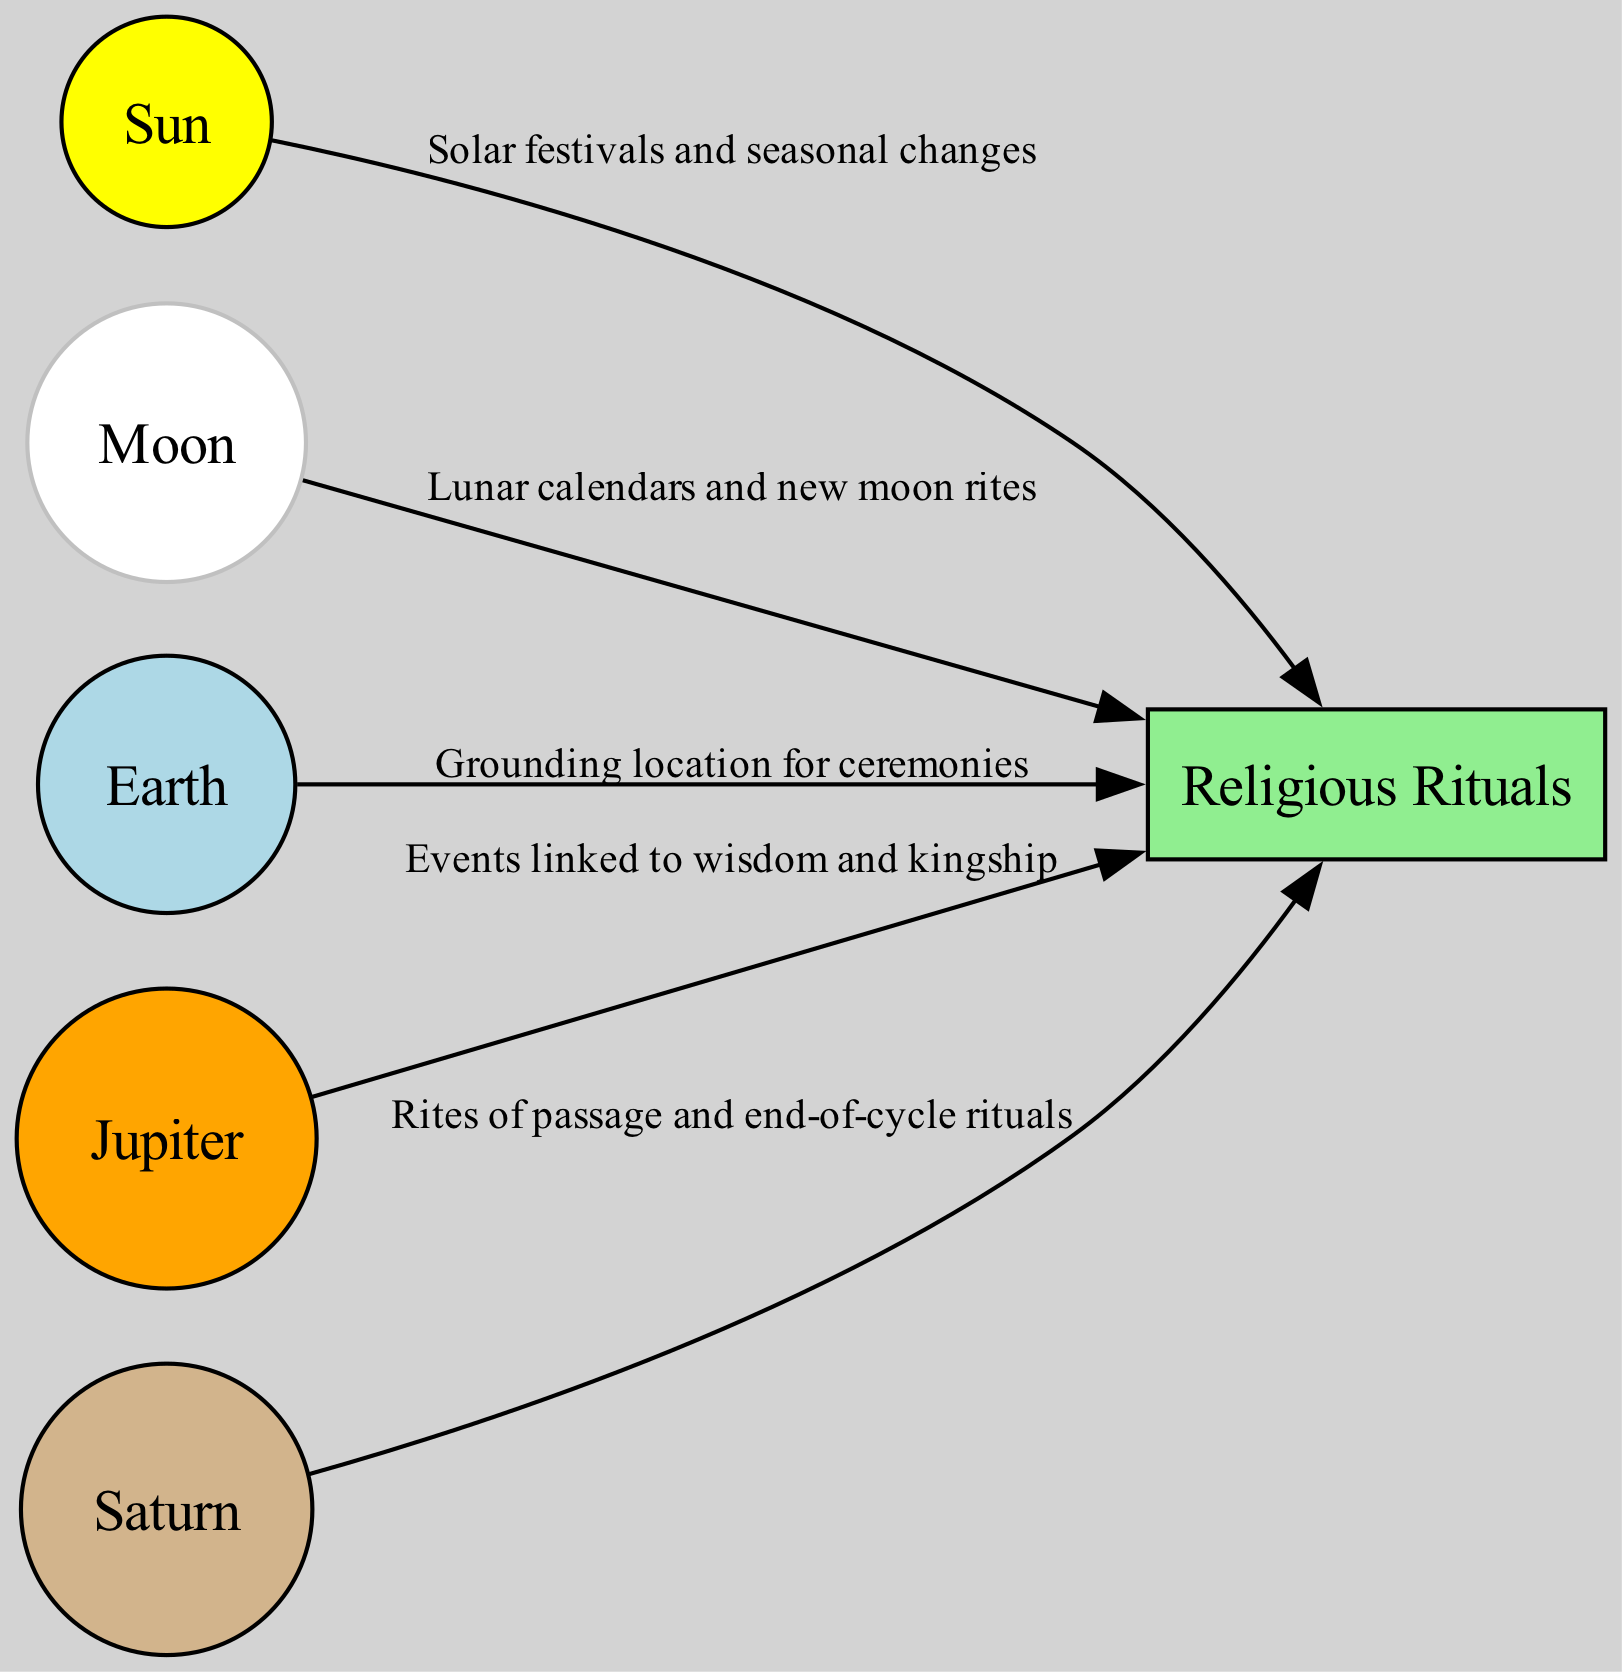What is the total number of nodes in the diagram? The diagram contains six distinct nodes, which are Sun, Moon, Earth, Jupiter, Saturn, and Religious Rituals. I can count them directly from the nodes section provided.
Answer: 6 What is the main influence of the Sun in religious practices? The edge labeled "Solar festivals and seasonal changes" shows that the Sun affects religious rituals regarding festivals and seasonal observations.
Answer: Solar festivals and seasonal changes Which planet is associated with wisdom? The label associated with Jupiter mentions its connection to wisdom and kingly aspects in mythology, which indicates that this planet has the influence of wisdom in religious rituals.
Answer: Jupiter How many edges are connecting the planets to the Religious Rituals node? By examining the edges, there are four connections from Sun, Moon, Jupiter, and Saturn leading to the Religious Rituals node. This means there are four edges in total connecting the planets.
Answer: 4 What is the significance of Saturn in religious rituals? The edge indicating "Rites of passage and end-of-cycle rituals" suggests that Saturn symbolizes time and is integral to rituals marking transitions in life.
Answer: Rites of passage and end-of-cycle rituals What is the connection between the Moon and Religious Rituals based on lunar events? The edge labeled "Lunar calendars and new moon rites" shows that the Moon's influence relates specifically to lunar events and their importance in rituals.
Answer: Lunar calendars and new moon rites Which node serves as the grounding location for ceremonies? The description for Earth indicates it is the location where religious observances occur, making it the grounding location for related ceremonies.
Answer: Earth How does Jupiter influence religious practices linked to kingship? The edge labeled "Events linked to wisdom and kingship" signifies that Jupiter's influence is related to both wisdom and its association with kingship, impacting ritual practices surrounding leadership.
Answer: Events linked to wisdom and kingship 